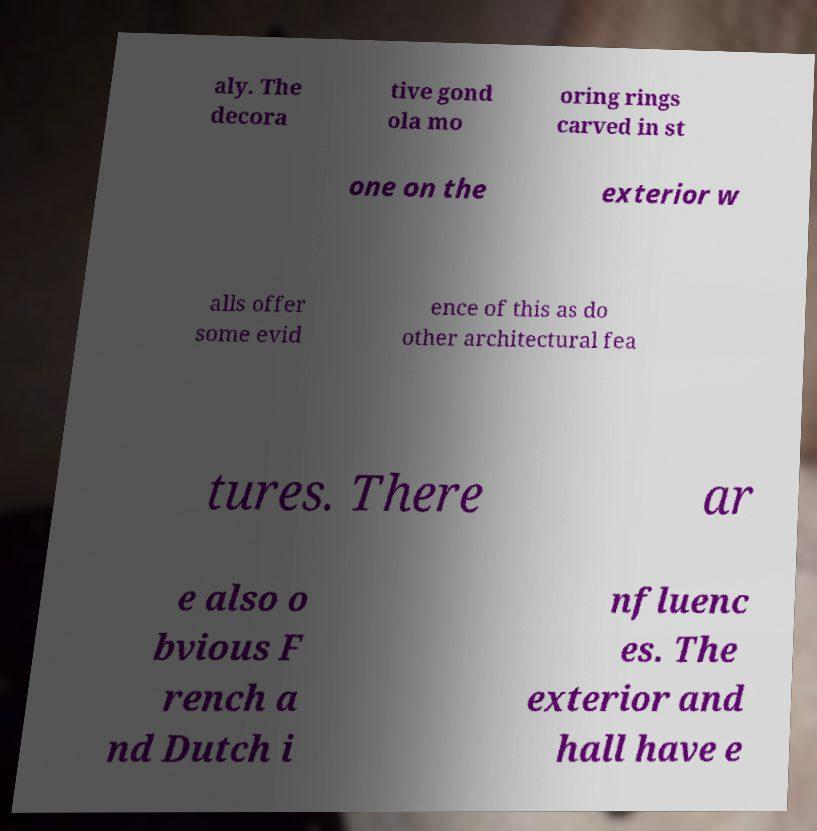Can you accurately transcribe the text from the provided image for me? aly. The decora tive gond ola mo oring rings carved in st one on the exterior w alls offer some evid ence of this as do other architectural fea tures. There ar e also o bvious F rench a nd Dutch i nfluenc es. The exterior and hall have e 